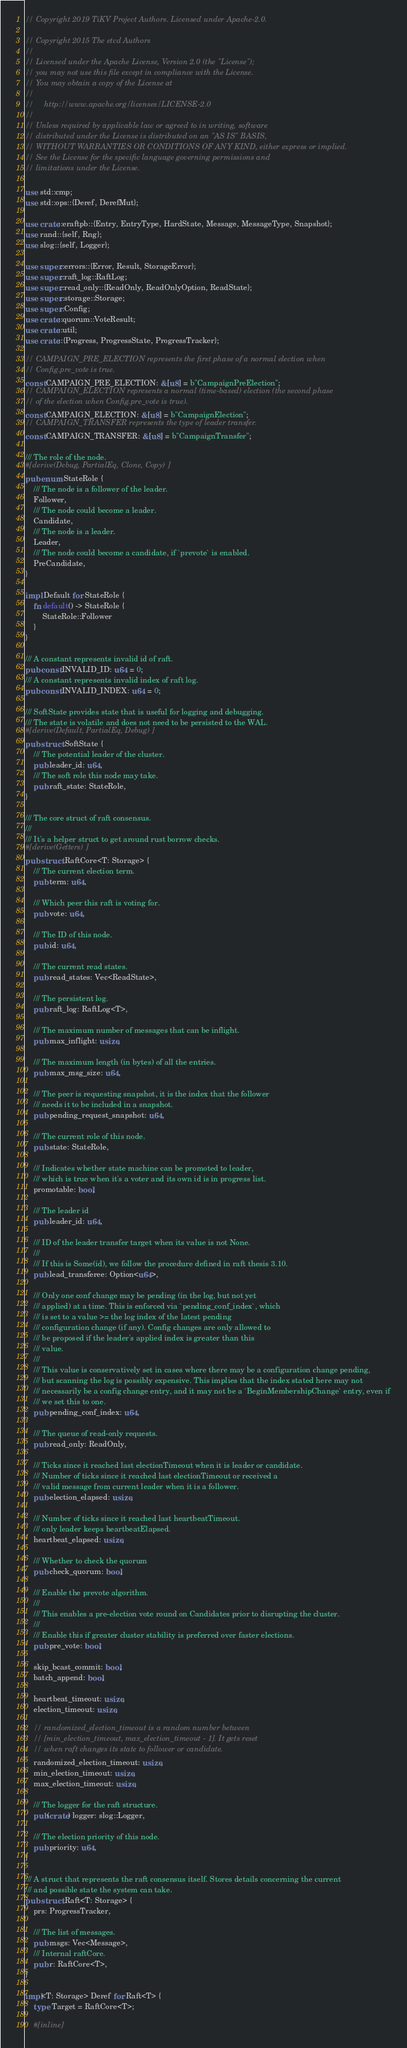<code> <loc_0><loc_0><loc_500><loc_500><_Rust_>// Copyright 2019 TiKV Project Authors. Licensed under Apache-2.0.

// Copyright 2015 The etcd Authors
//
// Licensed under the Apache License, Version 2.0 (the "License");
// you may not use this file except in compliance with the License.
// You may obtain a copy of the License at
//
//     http://www.apache.org/licenses/LICENSE-2.0
//
// Unless required by applicable law or agreed to in writing, software
// distributed under the License is distributed on an "AS IS" BASIS,
// WITHOUT WARRANTIES OR CONDITIONS OF ANY KIND, either express or implied.
// See the License for the specific language governing permissions and
// limitations under the License.

use std::cmp;
use std::ops::{Deref, DerefMut};

use crate::eraftpb::{Entry, EntryType, HardState, Message, MessageType, Snapshot};
use rand::{self, Rng};
use slog::{self, Logger};

use super::errors::{Error, Result, StorageError};
use super::raft_log::RaftLog;
use super::read_only::{ReadOnly, ReadOnlyOption, ReadState};
use super::storage::Storage;
use super::Config;
use crate::quorum::VoteResult;
use crate::util;
use crate::{Progress, ProgressState, ProgressTracker};

// CAMPAIGN_PRE_ELECTION represents the first phase of a normal election when
// Config.pre_vote is true.
const CAMPAIGN_PRE_ELECTION: &[u8] = b"CampaignPreElection";
// CAMPAIGN_ELECTION represents a normal (time-based) election (the second phase
// of the election when Config.pre_vote is true).
const CAMPAIGN_ELECTION: &[u8] = b"CampaignElection";
// CAMPAIGN_TRANSFER represents the type of leader transfer.
const CAMPAIGN_TRANSFER: &[u8] = b"CampaignTransfer";

/// The role of the node.
#[derive(Debug, PartialEq, Clone, Copy)]
pub enum StateRole {
    /// The node is a follower of the leader.
    Follower,
    /// The node could become a leader.
    Candidate,
    /// The node is a leader.
    Leader,
    /// The node could become a candidate, if `prevote` is enabled.
    PreCandidate,
}

impl Default for StateRole {
    fn default() -> StateRole {
        StateRole::Follower
    }
}

/// A constant represents invalid id of raft.
pub const INVALID_ID: u64 = 0;
/// A constant represents invalid index of raft log.
pub const INVALID_INDEX: u64 = 0;

/// SoftState provides state that is useful for logging and debugging.
/// The state is volatile and does not need to be persisted to the WAL.
#[derive(Default, PartialEq, Debug)]
pub struct SoftState {
    /// The potential leader of the cluster.
    pub leader_id: u64,
    /// The soft role this node may take.
    pub raft_state: StateRole,
}

/// The core struct of raft consensus.
///
/// It's a helper struct to get around rust borrow checks.
#[derive(Getters)]
pub struct RaftCore<T: Storage> {
    /// The current election term.
    pub term: u64,

    /// Which peer this raft is voting for.
    pub vote: u64,

    /// The ID of this node.
    pub id: u64,

    /// The current read states.
    pub read_states: Vec<ReadState>,

    /// The persistent log.
    pub raft_log: RaftLog<T>,

    /// The maximum number of messages that can be inflight.
    pub max_inflight: usize,

    /// The maximum length (in bytes) of all the entries.
    pub max_msg_size: u64,

    /// The peer is requesting snapshot, it is the index that the follower
    /// needs it to be included in a snapshot.
    pub pending_request_snapshot: u64,

    /// The current role of this node.
    pub state: StateRole,

    /// Indicates whether state machine can be promoted to leader,
    /// which is true when it's a voter and its own id is in progress list.
    promotable: bool,

    /// The leader id
    pub leader_id: u64,

    /// ID of the leader transfer target when its value is not None.
    ///
    /// If this is Some(id), we follow the procedure defined in raft thesis 3.10.
    pub lead_transferee: Option<u64>,

    /// Only one conf change may be pending (in the log, but not yet
    /// applied) at a time. This is enforced via `pending_conf_index`, which
    /// is set to a value >= the log index of the latest pending
    /// configuration change (if any). Config changes are only allowed to
    /// be proposed if the leader's applied index is greater than this
    /// value.
    ///
    /// This value is conservatively set in cases where there may be a configuration change pending,
    /// but scanning the log is possibly expensive. This implies that the index stated here may not
    /// necessarily be a config change entry, and it may not be a `BeginMembershipChange` entry, even if
    /// we set this to one.
    pub pending_conf_index: u64,

    /// The queue of read-only requests.
    pub read_only: ReadOnly,

    /// Ticks since it reached last electionTimeout when it is leader or candidate.
    /// Number of ticks since it reached last electionTimeout or received a
    /// valid message from current leader when it is a follower.
    pub election_elapsed: usize,

    /// Number of ticks since it reached last heartbeatTimeout.
    /// only leader keeps heartbeatElapsed.
    heartbeat_elapsed: usize,

    /// Whether to check the quorum
    pub check_quorum: bool,

    /// Enable the prevote algorithm.
    ///
    /// This enables a pre-election vote round on Candidates prior to disrupting the cluster.
    ///
    /// Enable this if greater cluster stability is preferred over faster elections.
    pub pre_vote: bool,

    skip_bcast_commit: bool,
    batch_append: bool,

    heartbeat_timeout: usize,
    election_timeout: usize,

    // randomized_election_timeout is a random number between
    // [min_election_timeout, max_election_timeout - 1]. It gets reset
    // when raft changes its state to follower or candidate.
    randomized_election_timeout: usize,
    min_election_timeout: usize,
    max_election_timeout: usize,

    /// The logger for the raft structure.
    pub(crate) logger: slog::Logger,

    /// The election priority of this node.
    pub priority: u64,
}

/// A struct that represents the raft consensus itself. Stores details concerning the current
/// and possible state the system can take.
pub struct Raft<T: Storage> {
    prs: ProgressTracker,

    /// The list of messages.
    pub msgs: Vec<Message>,
    /// Internal raftCore.
    pub r: RaftCore<T>,
}

impl<T: Storage> Deref for Raft<T> {
    type Target = RaftCore<T>;

    #[inline]</code> 